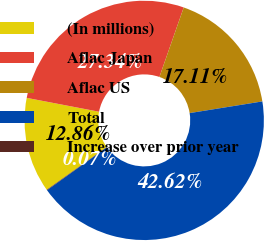Convert chart. <chart><loc_0><loc_0><loc_500><loc_500><pie_chart><fcel>(In millions)<fcel>Aflac Japan<fcel>Aflac US<fcel>Total<fcel>Increase over prior year<nl><fcel>12.86%<fcel>27.34%<fcel>17.11%<fcel>42.62%<fcel>0.07%<nl></chart> 